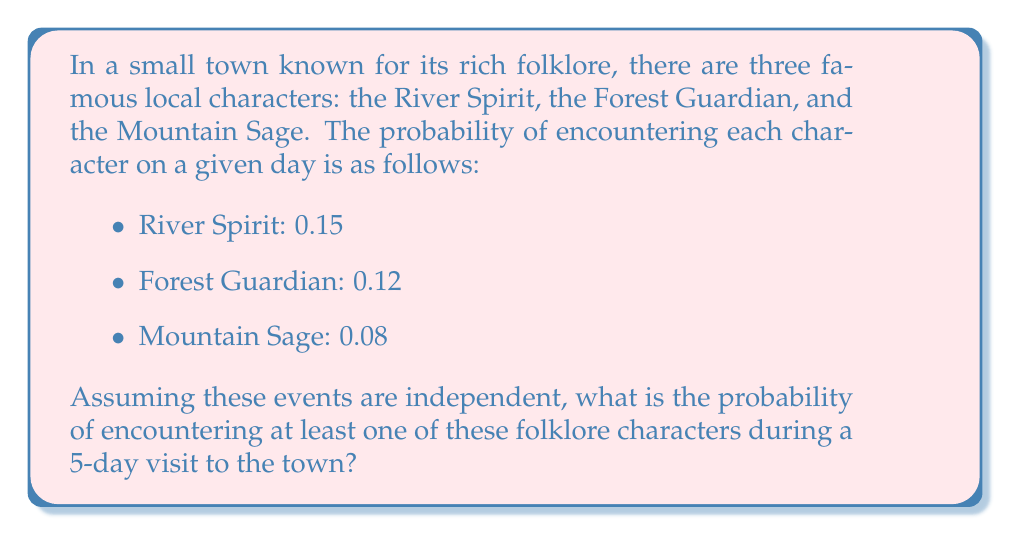Could you help me with this problem? Let's approach this step-by-step:

1) First, let's define our events:
   R: Encountering the River Spirit
   F: Encountering the Forest Guardian
   M: Encountering the Mountain Sage

2) We're looking for the probability of encountering at least one character in 5 days. It's easier to calculate the probability of not encountering any character and then subtract this from 1.

3) The probability of not encountering a specific character on a given day:
   P(not R) = 1 - 0.15 = 0.85
   P(not F) = 1 - 0.12 = 0.88
   P(not M) = 1 - 0.08 = 0.92

4) The probability of not encountering any character on a given day:
   P(no character) = P(not R and not F and not M)
                   = 0.85 * 0.88 * 0.92 = 0.6877

5) The probability of not encountering any character for all 5 days:
   P(no character for 5 days) = $(0.6877)^5$ = 0.1552

6) Therefore, the probability of encountering at least one character in 5 days is:
   P(at least one) = 1 - P(no character for 5 days)
                   = 1 - 0.1552 = 0.8448
Answer: 0.8448 or 84.48% 